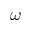<formula> <loc_0><loc_0><loc_500><loc_500>\omega</formula> 